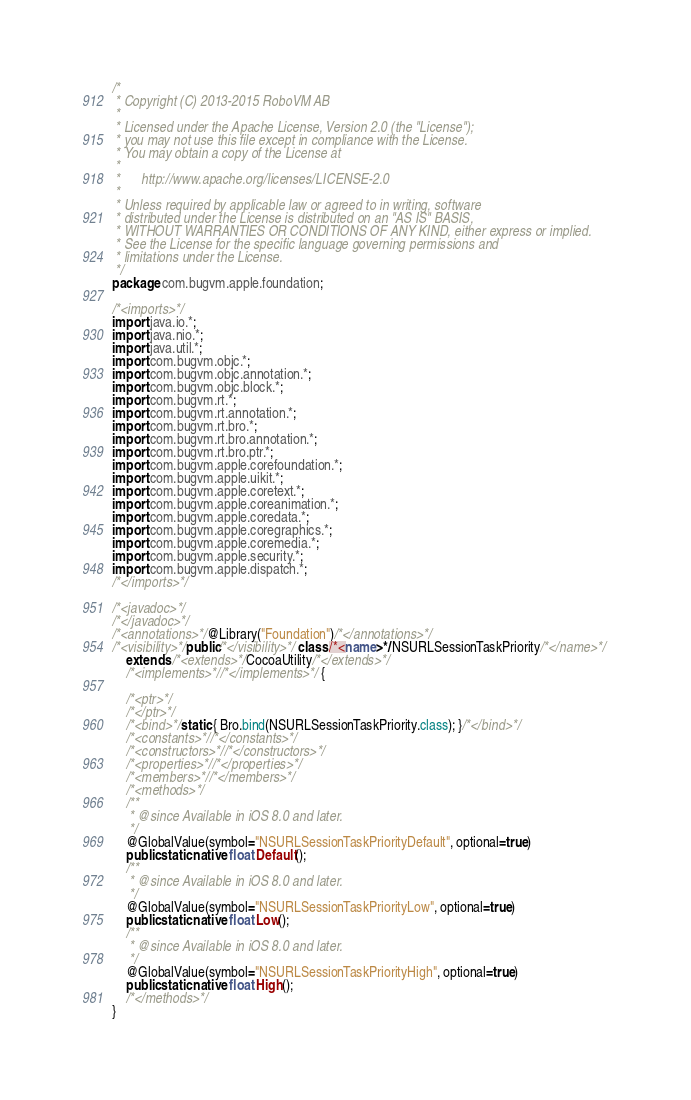Convert code to text. <code><loc_0><loc_0><loc_500><loc_500><_Java_>/*
 * Copyright (C) 2013-2015 RoboVM AB
 *
 * Licensed under the Apache License, Version 2.0 (the "License");
 * you may not use this file except in compliance with the License.
 * You may obtain a copy of the License at
 *
 *      http://www.apache.org/licenses/LICENSE-2.0
 *
 * Unless required by applicable law or agreed to in writing, software
 * distributed under the License is distributed on an "AS IS" BASIS,
 * WITHOUT WARRANTIES OR CONDITIONS OF ANY KIND, either express or implied.
 * See the License for the specific language governing permissions and
 * limitations under the License.
 */
package com.bugvm.apple.foundation;

/*<imports>*/
import java.io.*;
import java.nio.*;
import java.util.*;
import com.bugvm.objc.*;
import com.bugvm.objc.annotation.*;
import com.bugvm.objc.block.*;
import com.bugvm.rt.*;
import com.bugvm.rt.annotation.*;
import com.bugvm.rt.bro.*;
import com.bugvm.rt.bro.annotation.*;
import com.bugvm.rt.bro.ptr.*;
import com.bugvm.apple.corefoundation.*;
import com.bugvm.apple.uikit.*;
import com.bugvm.apple.coretext.*;
import com.bugvm.apple.coreanimation.*;
import com.bugvm.apple.coredata.*;
import com.bugvm.apple.coregraphics.*;
import com.bugvm.apple.coremedia.*;
import com.bugvm.apple.security.*;
import com.bugvm.apple.dispatch.*;
/*</imports>*/

/*<javadoc>*/
/*</javadoc>*/
/*<annotations>*/@Library("Foundation")/*</annotations>*/
/*<visibility>*/public/*</visibility>*/ class /*<name>*/NSURLSessionTaskPriority/*</name>*/ 
    extends /*<extends>*/CocoaUtility/*</extends>*/ 
    /*<implements>*//*</implements>*/ {

    /*<ptr>*/
    /*</ptr>*/
    /*<bind>*/static { Bro.bind(NSURLSessionTaskPriority.class); }/*</bind>*/
    /*<constants>*//*</constants>*/
    /*<constructors>*//*</constructors>*/
    /*<properties>*//*</properties>*/
    /*<members>*//*</members>*/
    /*<methods>*/
    /**
     * @since Available in iOS 8.0 and later.
     */
    @GlobalValue(symbol="NSURLSessionTaskPriorityDefault", optional=true)
    public static native float Default();
    /**
     * @since Available in iOS 8.0 and later.
     */
    @GlobalValue(symbol="NSURLSessionTaskPriorityLow", optional=true)
    public static native float Low();
    /**
     * @since Available in iOS 8.0 and later.
     */
    @GlobalValue(symbol="NSURLSessionTaskPriorityHigh", optional=true)
    public static native float High();
    /*</methods>*/
}
</code> 